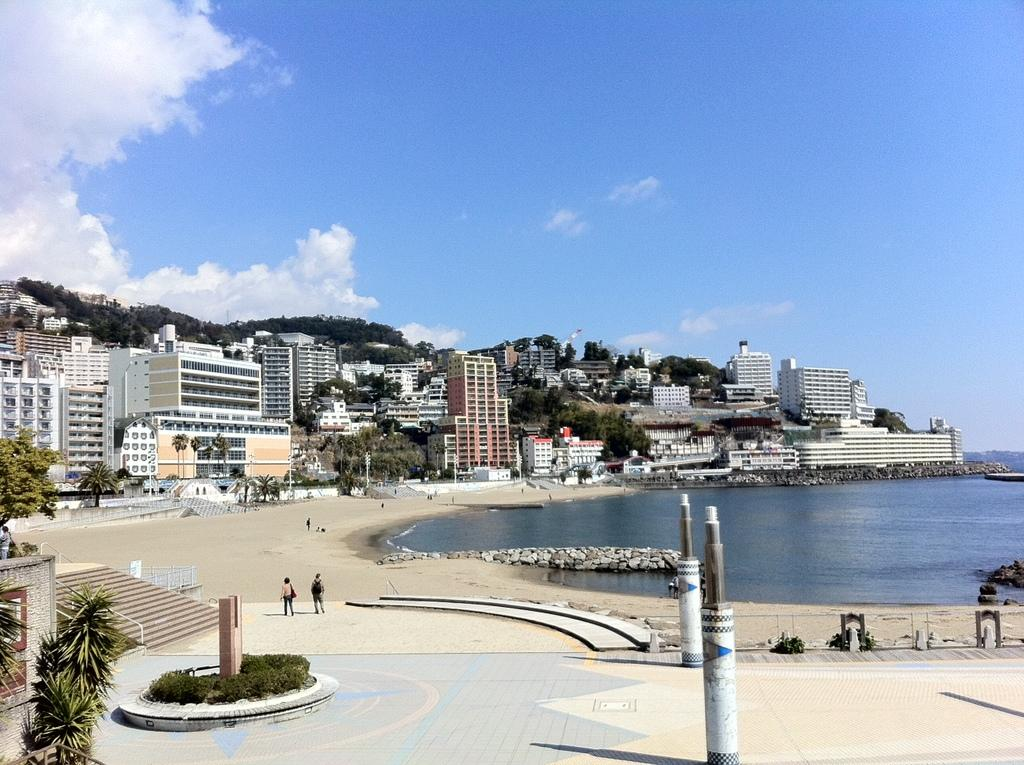What can be seen on the right side of the image? There is water on the right side of the image. What type of structures are present in the image? There are buildings in the image. What other natural elements can be seen in the image? There are trees in the image. Are there any people visible in the image? Yes, there are people in the image. What else can be seen in the image besides the water, buildings, trees, and people? There are poles in the image. What is visible in the background of the image? The sky with clouds is visible in the background of the image. Can you hear the bells ringing in the image? There are no bells present in the image, so it is not possible to hear them ringing. 